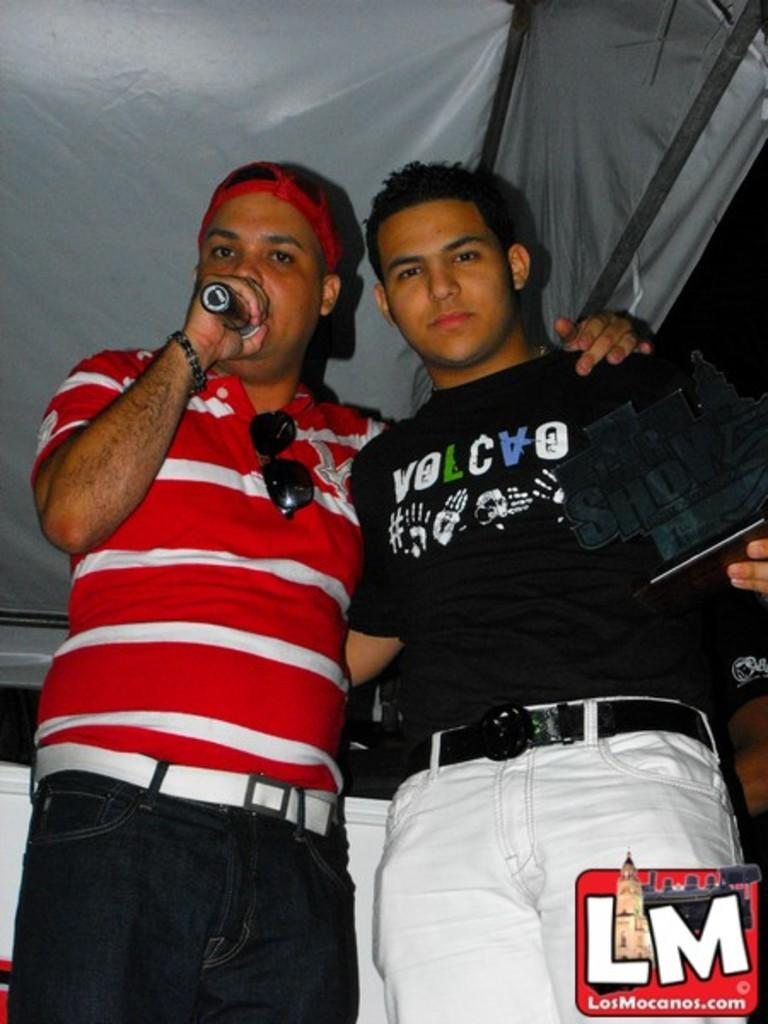<image>
Create a compact narrative representing the image presented. A man in a red and white striped shirt talks into a microphone with his arm around another man in this photo with a LosMocanos.com logo in the bottom corner. 